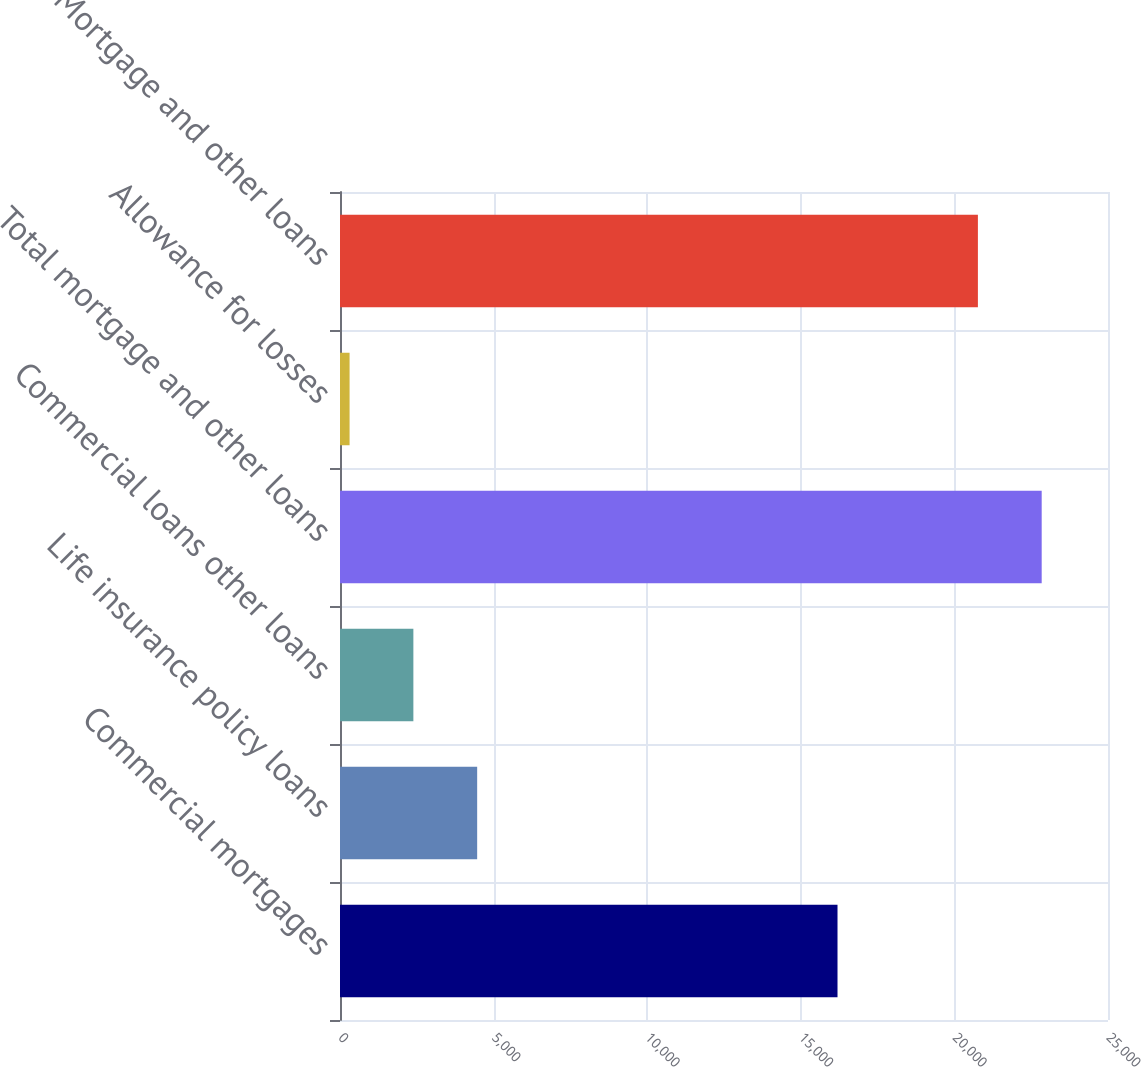Convert chart. <chart><loc_0><loc_0><loc_500><loc_500><bar_chart><fcel>Commercial mortgages<fcel>Life insurance policy loans<fcel>Commercial loans other loans<fcel>Total mortgage and other loans<fcel>Allowance for losses<fcel>Mortgage and other loans<nl><fcel>16195<fcel>4465<fcel>2388.5<fcel>22841.5<fcel>312<fcel>20765<nl></chart> 